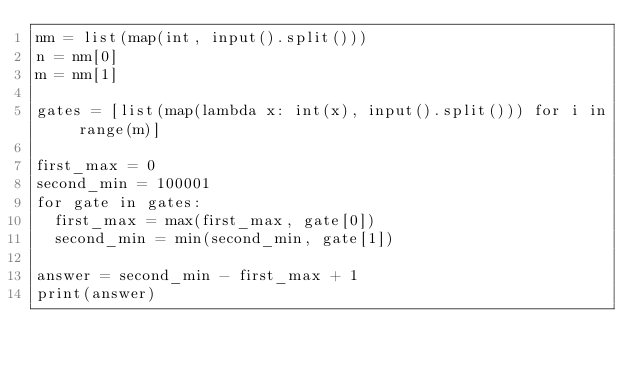Convert code to text. <code><loc_0><loc_0><loc_500><loc_500><_Python_>nm = list(map(int, input().split()))
n = nm[0]
m = nm[1]

gates = [list(map(lambda x: int(x), input().split())) for i in range(m)]

first_max = 0
second_min = 100001
for gate in gates:
  first_max = max(first_max, gate[0])
  second_min = min(second_min, gate[1])

answer = second_min - first_max + 1
print(answer)</code> 